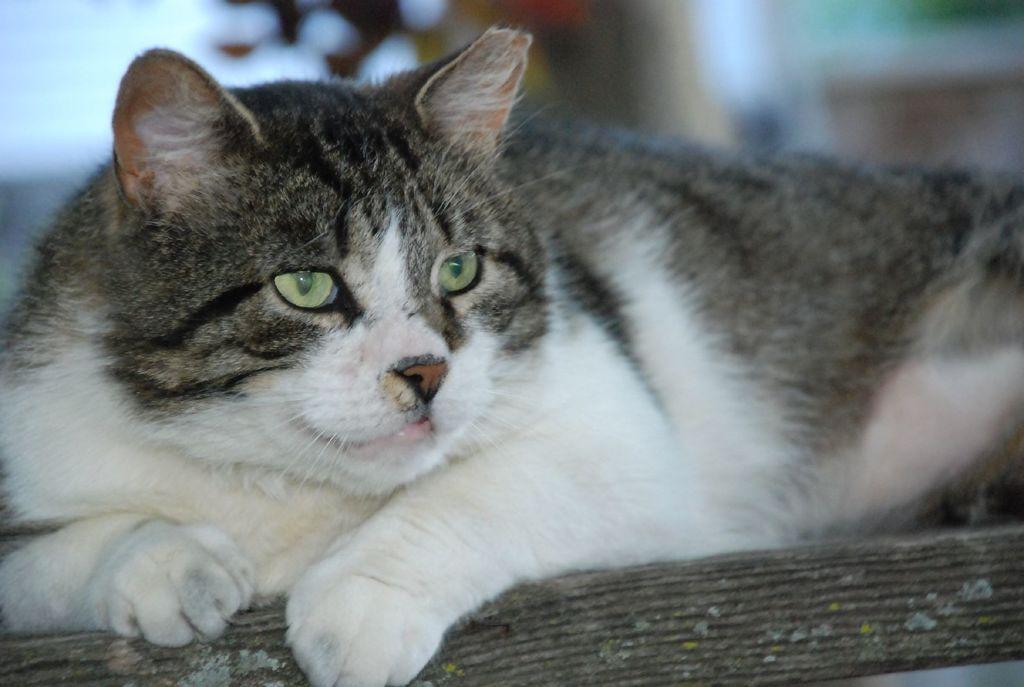How would you summarize this image in a sentence or two? This picture shows a cat it is white and it is white and black in color. 